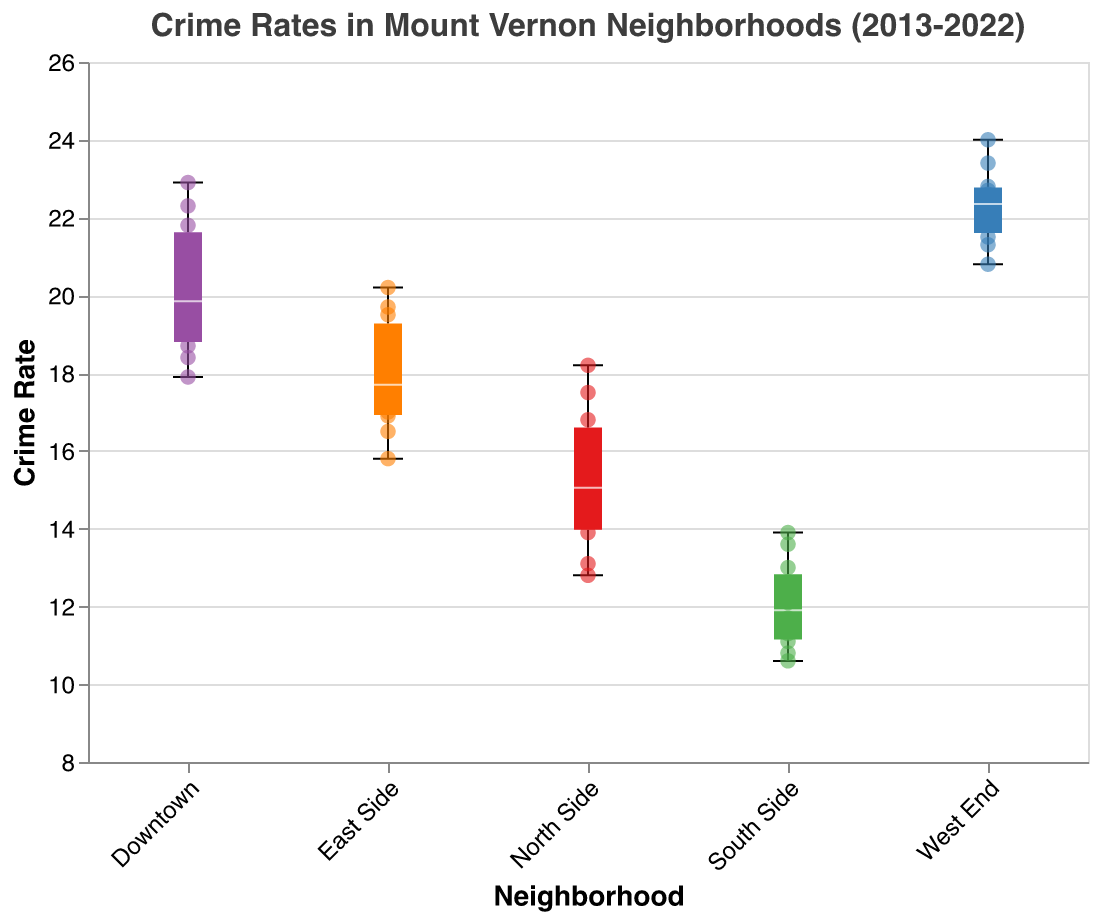What's the median crime rate in the South Side neighborhood? To find the median crime rate in the South Side, one would observe the white line inside the box of the South Side box plot.
Answer: 12.1 Which neighborhood has the highest median crime rate? By looking at the white lines inside the boxes, the neighborhood with the highest median line is the West End.
Answer: West End What is the range of crime rates in North Side? To determine the range, find the minimum and maximum points in the North Side box plot. The lowest point is 12.8 and the highest is 18.2. The range is 18.2 - 12.8 = 5.4.
Answer: 5.4 How does the interquartile range (IQR) of Downtown compare to the IQR of East Side? The IQR is the range between the first quartile (bottom of the box) and the third quartile (top of the box). The IQR of Downtown appears to be greater than that of East Side as the box length of Downtown is longer.
Answer: Downtown > East Side Which neighborhood shows the most variability in crime rates? Variability is indicated by the total length from the minimum to the maximum point in each box plot. The West End shows the most variability as it has the longest length from the minimum to the maximum point.
Answer: West End Are any of the neighborhoods' crime rates consistently increasing over the given years? By observing the scatter points, we can evaluate year-on-year trends. Both Downtown and East Side show an increasing trend in scatter points from 2013 to 2022.
Answer: Downtown, East Side What is the highest recorded crime rate from all the neighborhoods? The highest recorded crime rate can be identified by the topmost scatter point in any of the box plots. This occurs in Downtown in 2022 with a value of 22.9.
Answer: 22.9 Is the crime rate in the South Side ever higher than the median crime rate of the West End? To determine this, compare scatter points of the South Side to the median line (white line) of the West End box plot. No scatter point from South Side surpasses the median line of West End around 22.6.
Answer: No What is the difference between the median crime rates of North Side and Downtown? The median crime rate for Downtown is 19.3 and for North Side is 14.2. The difference is calculated as 19.3 - 14.2 = 5.1.
Answer: 5.1 